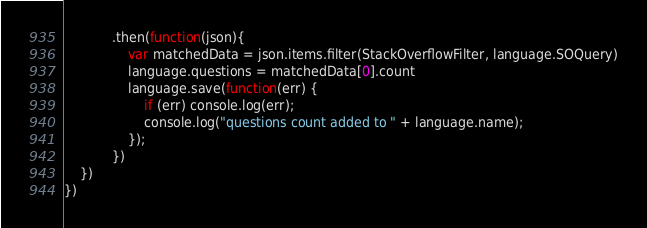Convert code to text. <code><loc_0><loc_0><loc_500><loc_500><_JavaScript_>			.then(function(json){
				var matchedData = json.items.filter(StackOverflowFilter, language.SOQuery)
				language.questions = matchedData[0].count
				language.save(function(err) {
					if (err) console.log(err);
					console.log("questions count added to " + language.name);
				});
			})
	})	
})

</code> 